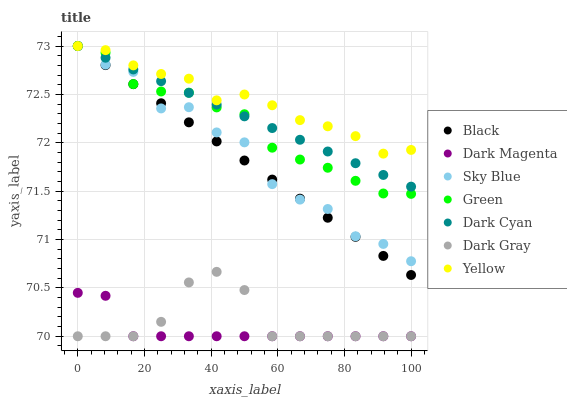Does Dark Magenta have the minimum area under the curve?
Answer yes or no. Yes. Does Yellow have the maximum area under the curve?
Answer yes or no. Yes. Does Dark Gray have the minimum area under the curve?
Answer yes or no. No. Does Dark Gray have the maximum area under the curve?
Answer yes or no. No. Is Black the smoothest?
Answer yes or no. Yes. Is Sky Blue the roughest?
Answer yes or no. Yes. Is Yellow the smoothest?
Answer yes or no. No. Is Yellow the roughest?
Answer yes or no. No. Does Dark Magenta have the lowest value?
Answer yes or no. Yes. Does Yellow have the lowest value?
Answer yes or no. No. Does Sky Blue have the highest value?
Answer yes or no. Yes. Does Dark Gray have the highest value?
Answer yes or no. No. Is Dark Magenta less than Yellow?
Answer yes or no. Yes. Is Yellow greater than Dark Magenta?
Answer yes or no. Yes. Does Sky Blue intersect Dark Cyan?
Answer yes or no. Yes. Is Sky Blue less than Dark Cyan?
Answer yes or no. No. Is Sky Blue greater than Dark Cyan?
Answer yes or no. No. Does Dark Magenta intersect Yellow?
Answer yes or no. No. 